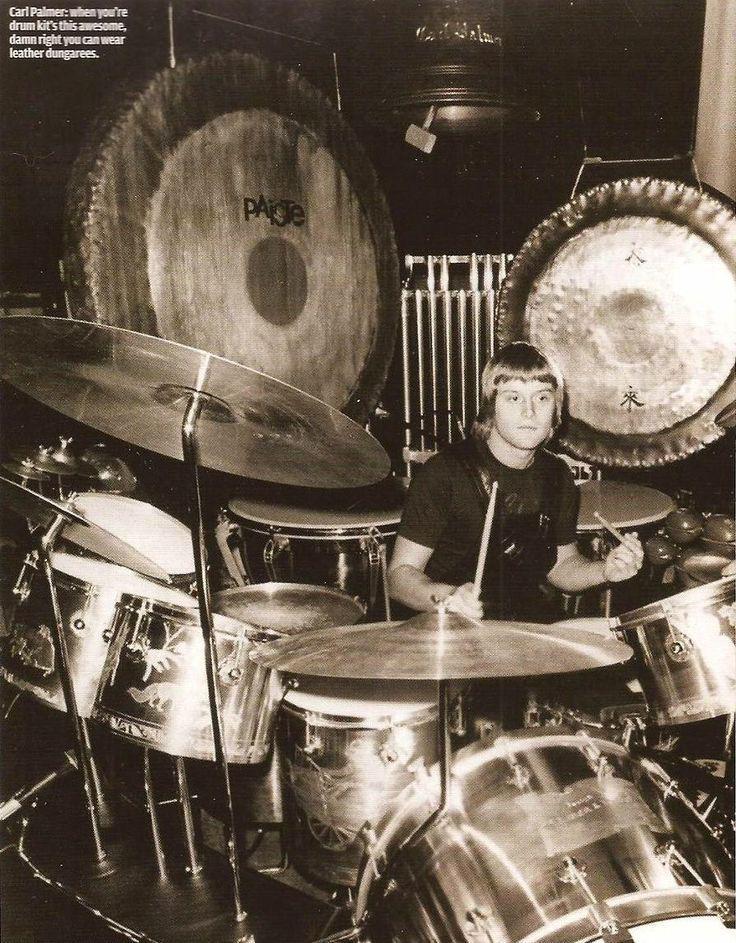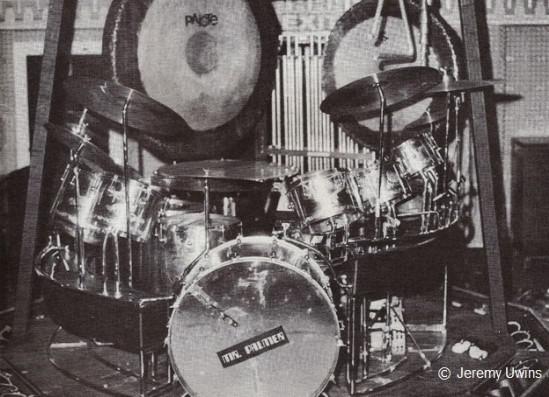The first image is the image on the left, the second image is the image on the right. Analyze the images presented: Is the assertion "There is a man in one image, but not the other." valid? Answer yes or no. Yes. The first image is the image on the left, the second image is the image on the right. For the images shown, is this caption "The image to the left is a color image (not black & white) and features steel drums." true? Answer yes or no. No. 